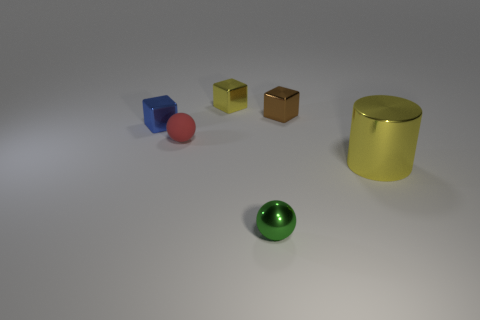How many green spheres have the same size as the yellow metal cylinder?
Your response must be concise. 0. Are there fewer matte spheres that are behind the blue cube than large metal cylinders on the left side of the small red rubber sphere?
Provide a short and direct response. No. What number of matte things are small blue things or tiny brown cylinders?
Ensure brevity in your answer.  0. What shape is the blue object?
Offer a very short reply. Cube. There is a blue block that is the same size as the red matte thing; what is its material?
Your response must be concise. Metal. How many large things are either metal cubes or blue cubes?
Make the answer very short. 0. Are any blocks visible?
Make the answer very short. Yes. What size is the sphere that is made of the same material as the blue block?
Offer a terse response. Small. Is the blue object made of the same material as the yellow cube?
Keep it short and to the point. Yes. How many other objects are there of the same material as the blue block?
Ensure brevity in your answer.  4. 